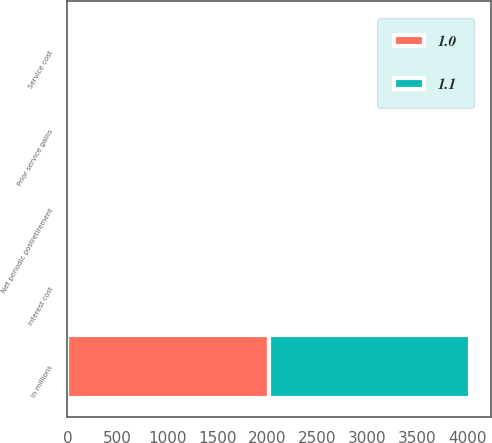Convert chart to OTSL. <chart><loc_0><loc_0><loc_500><loc_500><stacked_bar_chart><ecel><fcel>In millions<fcel>Service cost<fcel>Interest cost<fcel>Prior service gains<fcel>Net periodic postretirement<nl><fcel>1.1<fcel>2016<fcel>0.1<fcel>0.4<fcel>1.6<fcel>1.1<nl><fcel>1<fcel>2015<fcel>0.1<fcel>0.5<fcel>1.6<fcel>1<nl></chart> 